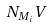Convert formula to latex. <formula><loc_0><loc_0><loc_500><loc_500>N _ { M _ { i } } V</formula> 